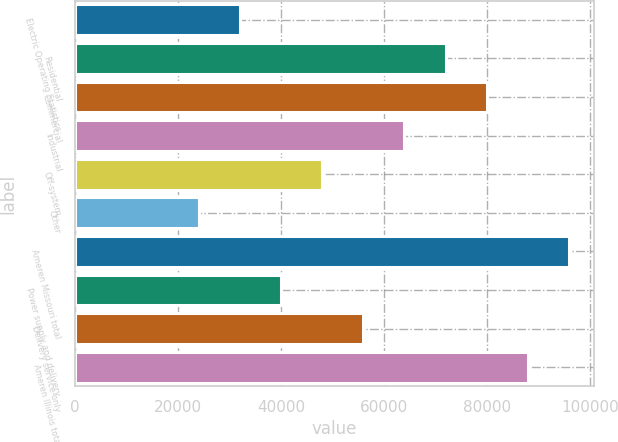Convert chart. <chart><loc_0><loc_0><loc_500><loc_500><bar_chart><fcel>Electric Operating Statistics<fcel>Residential<fcel>Commercial<fcel>Industrial<fcel>Off-system<fcel>Other<fcel>Ameren Missouri total<fcel>Power supply and delivery<fcel>Delivery service only<fcel>Ameren Illinois total<nl><fcel>32000<fcel>71962.5<fcel>79955<fcel>63970<fcel>47985<fcel>24007.5<fcel>95940<fcel>39992.5<fcel>55977.5<fcel>87947.5<nl></chart> 